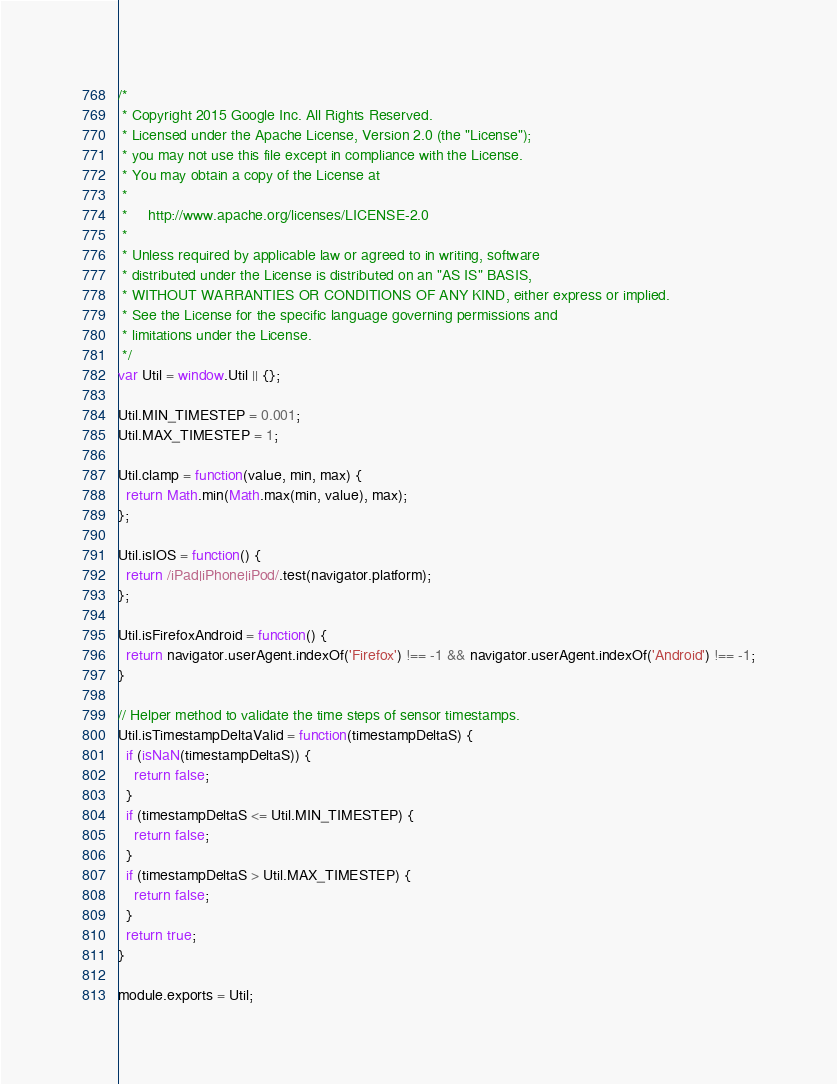<code> <loc_0><loc_0><loc_500><loc_500><_JavaScript_>/*
 * Copyright 2015 Google Inc. All Rights Reserved.
 * Licensed under the Apache License, Version 2.0 (the "License");
 * you may not use this file except in compliance with the License.
 * You may obtain a copy of the License at
 *
 *     http://www.apache.org/licenses/LICENSE-2.0
 *
 * Unless required by applicable law or agreed to in writing, software
 * distributed under the License is distributed on an "AS IS" BASIS,
 * WITHOUT WARRANTIES OR CONDITIONS OF ANY KIND, either express or implied.
 * See the License for the specific language governing permissions and
 * limitations under the License.
 */
var Util = window.Util || {};

Util.MIN_TIMESTEP = 0.001;
Util.MAX_TIMESTEP = 1;

Util.clamp = function(value, min, max) {
  return Math.min(Math.max(min, value), max);
};

Util.isIOS = function() {
  return /iPad|iPhone|iPod/.test(navigator.platform);
};

Util.isFirefoxAndroid = function() {
  return navigator.userAgent.indexOf('Firefox') !== -1 && navigator.userAgent.indexOf('Android') !== -1;
}

// Helper method to validate the time steps of sensor timestamps.
Util.isTimestampDeltaValid = function(timestampDeltaS) {
  if (isNaN(timestampDeltaS)) {
    return false;
  }
  if (timestampDeltaS <= Util.MIN_TIMESTEP) {
    return false;
  }
  if (timestampDeltaS > Util.MAX_TIMESTEP) {
    return false;
  }
  return true;
}

module.exports = Util;
</code> 